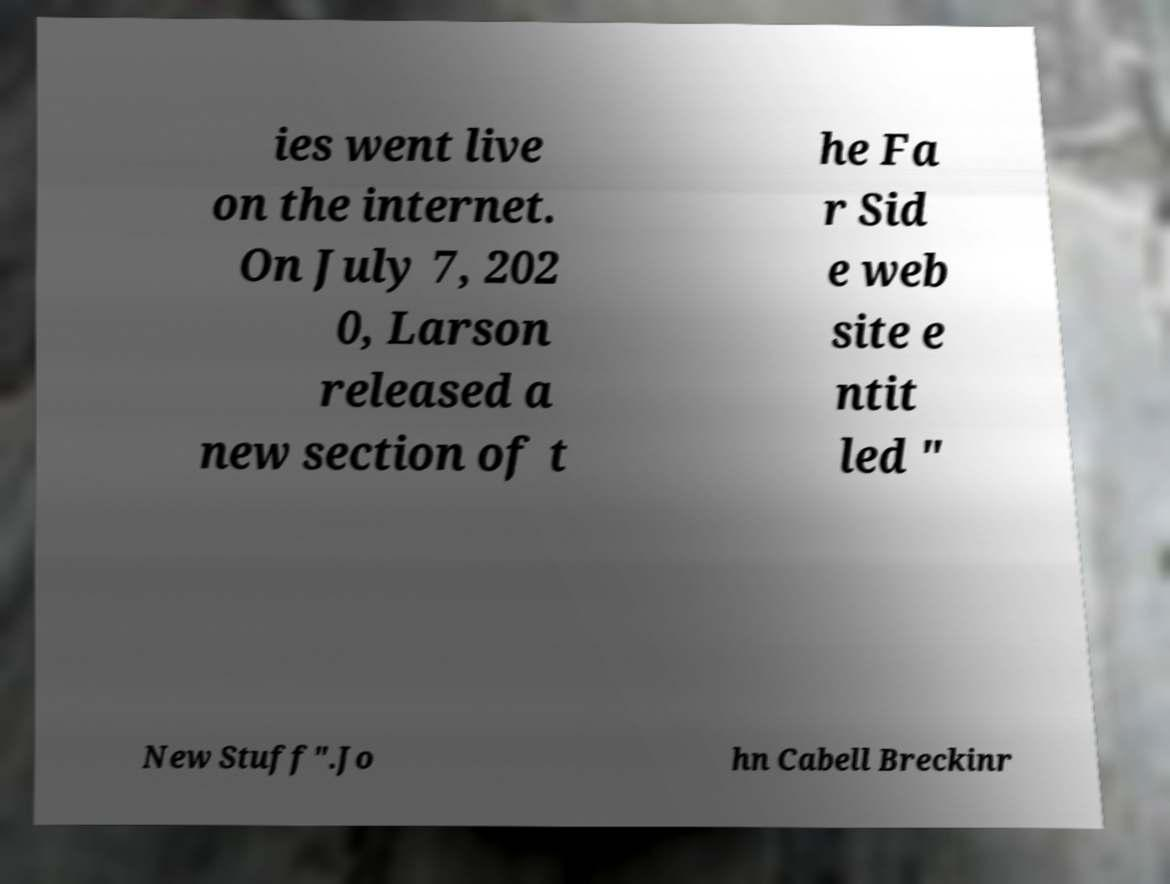Please read and relay the text visible in this image. What does it say? ies went live on the internet. On July 7, 202 0, Larson released a new section of t he Fa r Sid e web site e ntit led " New Stuff".Jo hn Cabell Breckinr 